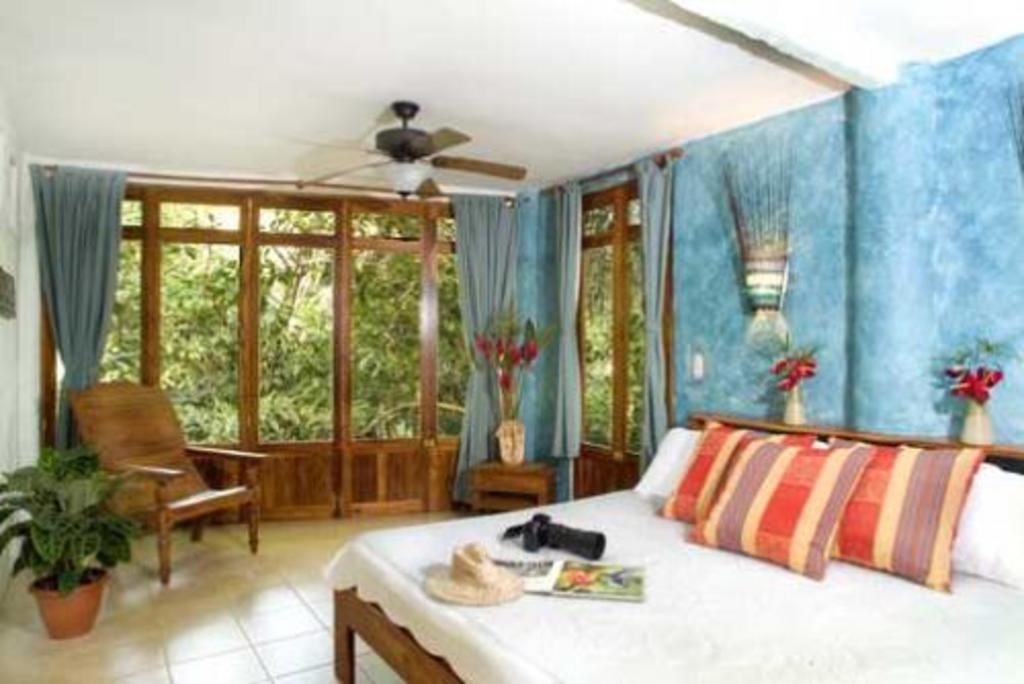How would you summarize this image in a sentence or two? This image is inside a room. We can see bed with pillows, camera, hat, book, chair, flower pots, curtains, glass windows and ceiling fan. 